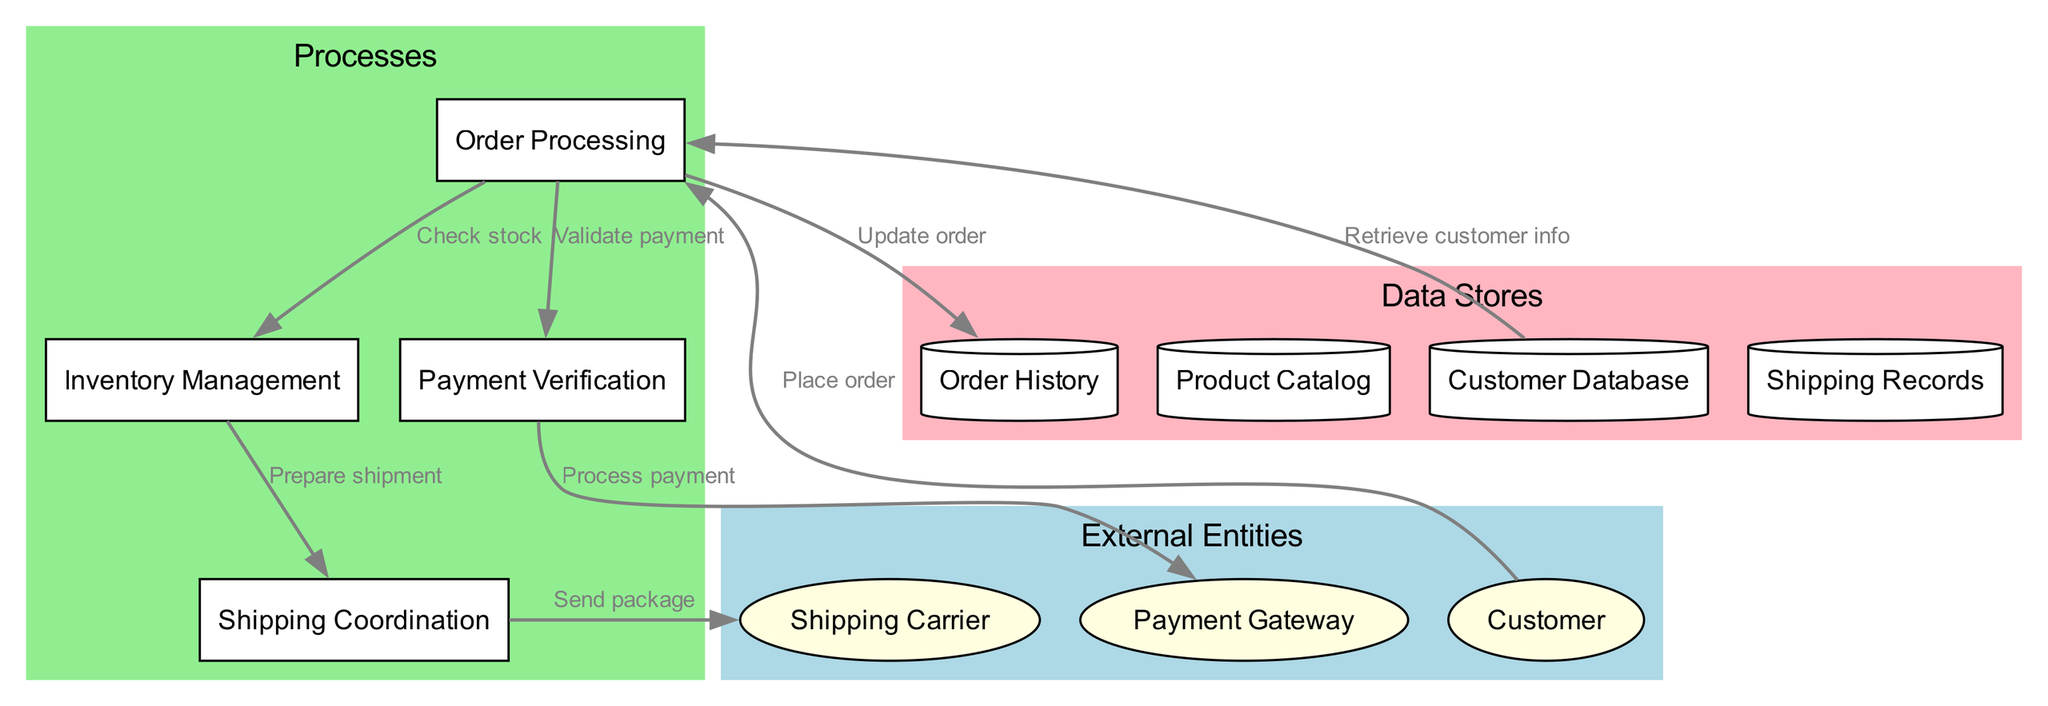What external entities are involved? The diagram lists three external entities: Customer, Payment Gateway, and Shipping Carrier. These are shown as ellipse-shaped nodes in the external entities section of the diagram.
Answer: Customer, Payment Gateway, Shipping Carrier How many processes are represented? There are four processes shown in the diagram, which can be verified by counting the rectangle-shaped nodes in the processes section.
Answer: Four What is the data flow from Order Processing to Inventory Management? In the diagram, there is a data flow indicated from Order Processing to Inventory Management labeled "Check stock". This shows the process of checking the available stock for the order.
Answer: Check stock Which data store receives information from Order Processing? The Order History data store receives an update from Order Processing, as indicated by the labeled data flow "Update order". This flow signifies that the order's status is recorded in this store.
Answer: Order History What process validates payment? The Payment Verification process is responsible for validating payment, as depicted in the flow from Order Processing to Payment Verification, labeled "Validate payment".
Answer: Payment Verification What does the Shipping Coordination process do with Inventory Management? The Shipping Coordination process receives the data from Inventory Management, labeled "Prepare shipment". This indicates that it organizes the shipment of the product based on the prepared inventory.
Answer: Prepare shipment How many data stores are present in the diagram? The diagram features four data stores, which can be counted in the data stores section, represented as cylinder-shaped nodes.
Answer: Four What is sent to the Shipping Carrier? The Shipping Coordination process sends the package to the Shipping Carrier, as denoted by the labeled data flow "Send package". This shows the action of delivering the package to the carrier for shipping.
Answer: Send package Which external entity processes payments? The Payment Gateway is the external entity that processes payments, as indicated by the flow from Payment Verification to Payment Gateway, labeled "Process payment". This flow signifies the action of processing payment transactions through the gateway.
Answer: Payment Gateway 